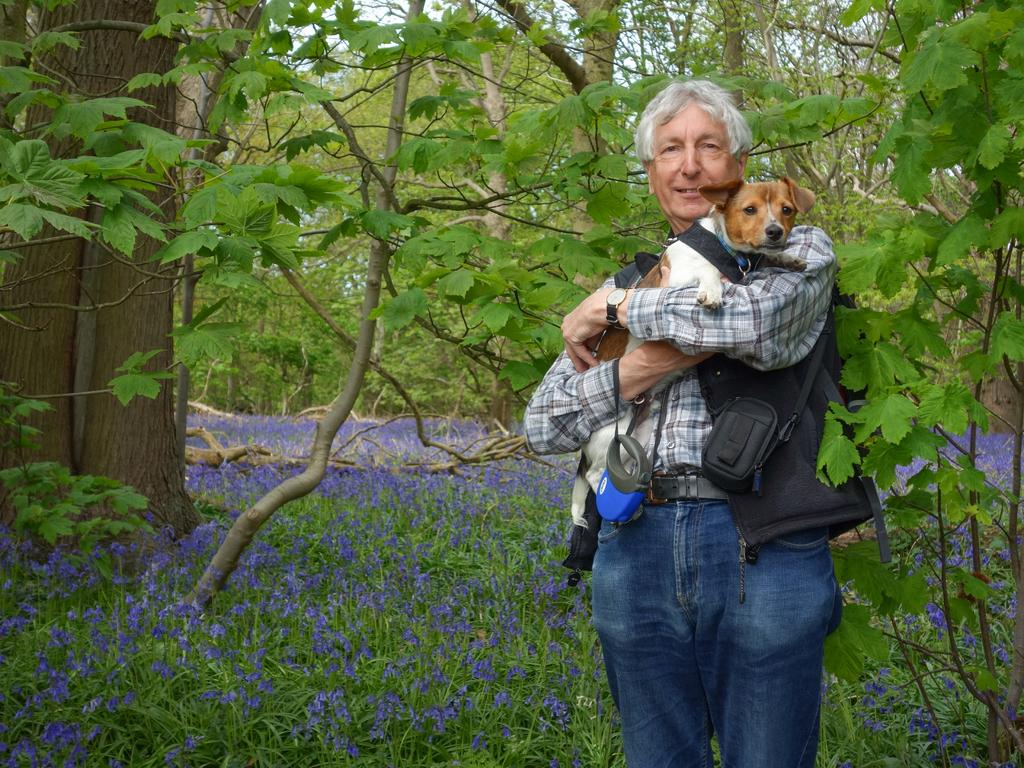What is the main subject of the image? There is a person in the image. What is the person doing in the image? The person is standing and holding a dog with his hands. What accessories is the person wearing in the image? The person is wearing clothes, a watch, and a bag. What can be seen in the background of the image? There are trees and plants in the background of the image. How many copies of the cat are visible in the image? There is no cat present in the image. What part of the person's body is missing in the image? The person's body is fully visible in the image, and no parts are missing. 